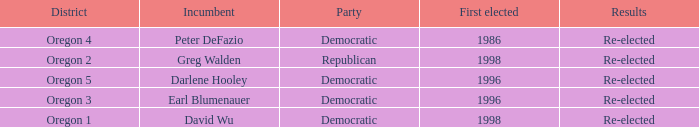Parse the table in full. {'header': ['District', 'Incumbent', 'Party', 'First elected', 'Results'], 'rows': [['Oregon 4', 'Peter DeFazio', 'Democratic', '1986', 'Re-elected'], ['Oregon 2', 'Greg Walden', 'Republican', '1998', 'Re-elected'], ['Oregon 5', 'Darlene Hooley', 'Democratic', '1996', 'Re-elected'], ['Oregon 3', 'Earl Blumenauer', 'Democratic', '1996', 'Re-elected'], ['Oregon 1', 'David Wu', 'Democratic', '1998', 'Re-elected']]} Which district has a Democratic incumbent that was first elected before 1996? Oregon 4. 